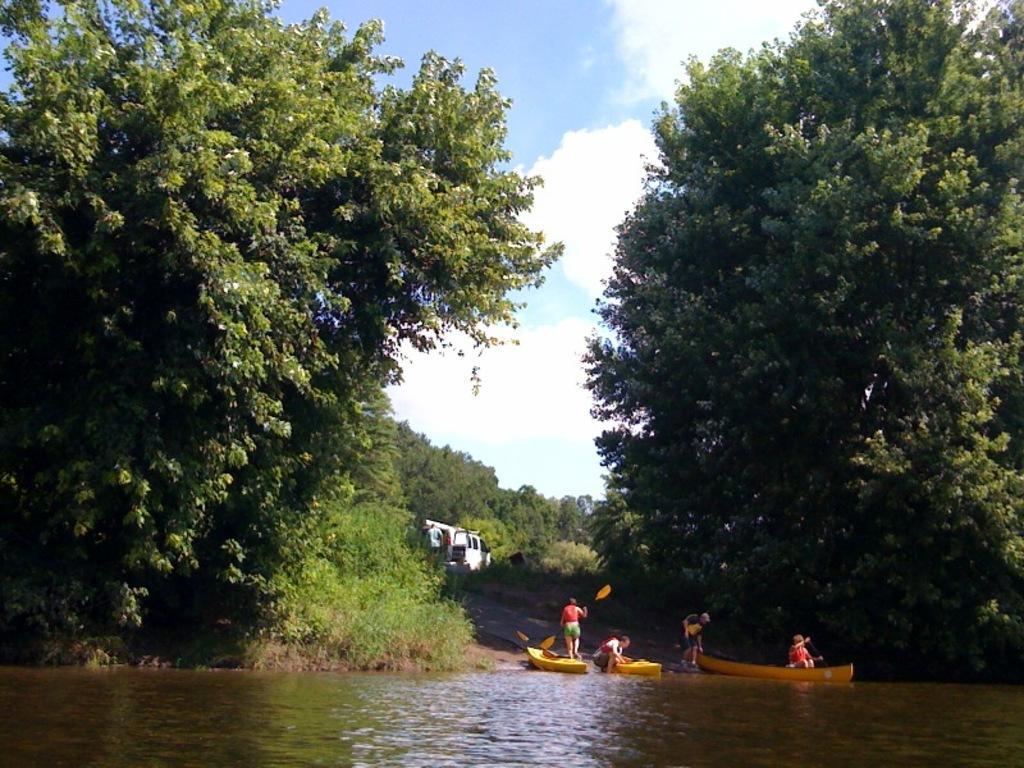Describe this image in one or two sentences. In this image we can see many trees and there are three boats present on the surface of the river. We can also see people. At the top there is sky with clouds. 